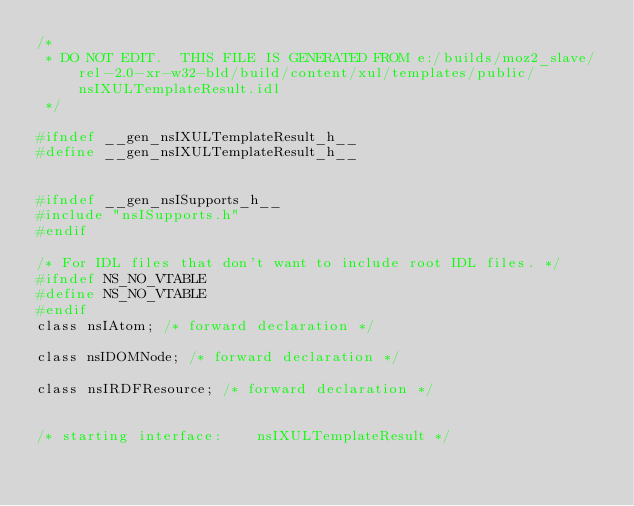<code> <loc_0><loc_0><loc_500><loc_500><_C_>/*
 * DO NOT EDIT.  THIS FILE IS GENERATED FROM e:/builds/moz2_slave/rel-2.0-xr-w32-bld/build/content/xul/templates/public/nsIXULTemplateResult.idl
 */

#ifndef __gen_nsIXULTemplateResult_h__
#define __gen_nsIXULTemplateResult_h__


#ifndef __gen_nsISupports_h__
#include "nsISupports.h"
#endif

/* For IDL files that don't want to include root IDL files. */
#ifndef NS_NO_VTABLE
#define NS_NO_VTABLE
#endif
class nsIAtom; /* forward declaration */

class nsIDOMNode; /* forward declaration */

class nsIRDFResource; /* forward declaration */


/* starting interface:    nsIXULTemplateResult */</code> 